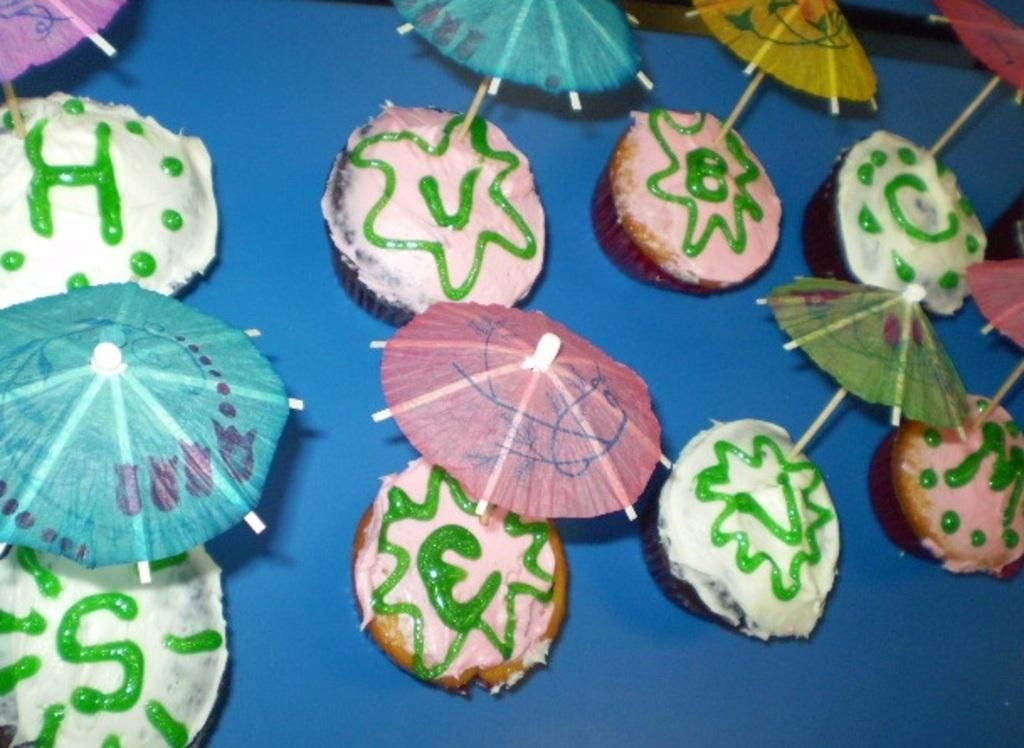What type of food can be seen in the image? There are cakes in the image. Where are the cakes located? The cakes are placed on a table. What type of clothing is visible on the toe in the image? There is no toe or clothing present in the image; it features cakes placed on a table. 